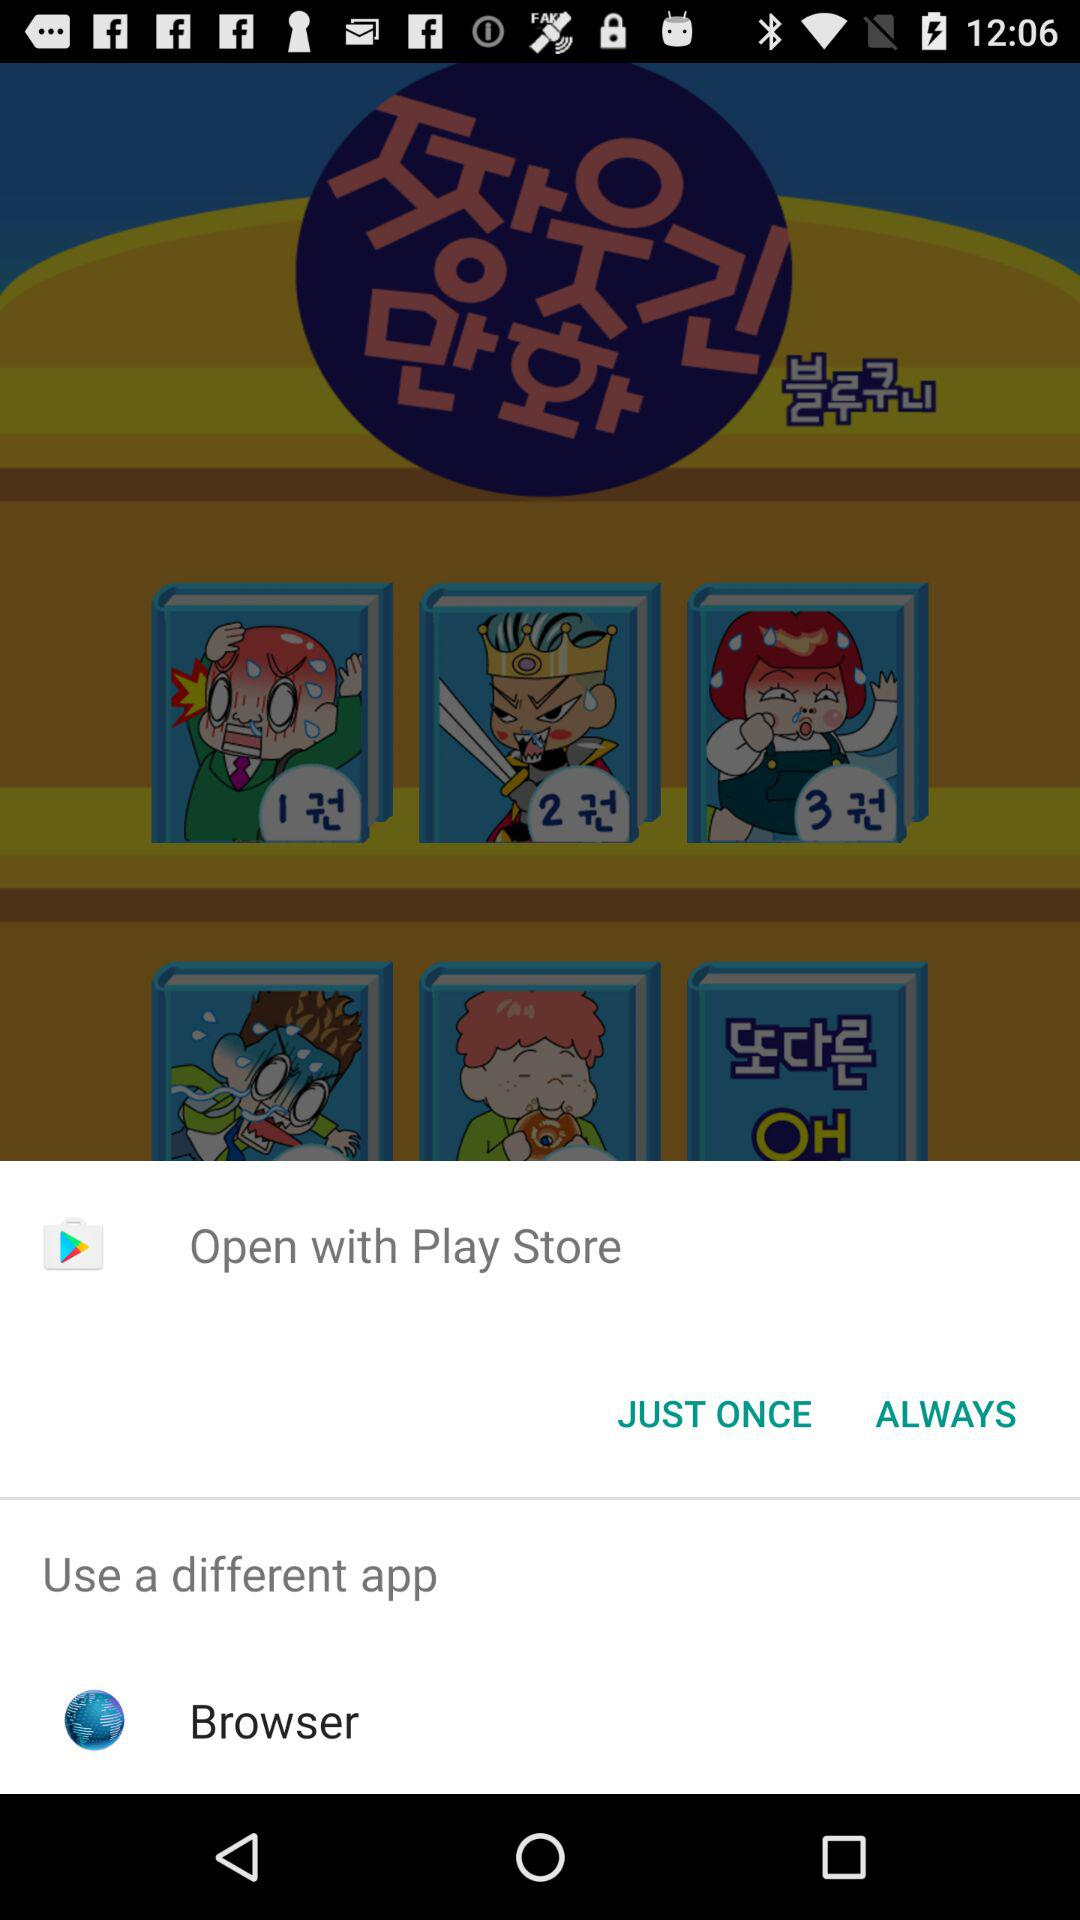Which application is used to open the content? You can open it with "Play Store" and "Browser". 